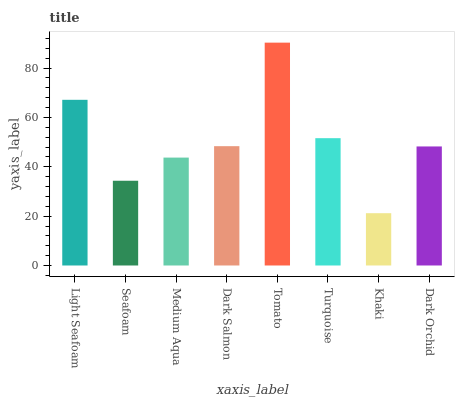Is Khaki the minimum?
Answer yes or no. Yes. Is Tomato the maximum?
Answer yes or no. Yes. Is Seafoam the minimum?
Answer yes or no. No. Is Seafoam the maximum?
Answer yes or no. No. Is Light Seafoam greater than Seafoam?
Answer yes or no. Yes. Is Seafoam less than Light Seafoam?
Answer yes or no. Yes. Is Seafoam greater than Light Seafoam?
Answer yes or no. No. Is Light Seafoam less than Seafoam?
Answer yes or no. No. Is Dark Salmon the high median?
Answer yes or no. Yes. Is Dark Orchid the low median?
Answer yes or no. Yes. Is Light Seafoam the high median?
Answer yes or no. No. Is Khaki the low median?
Answer yes or no. No. 